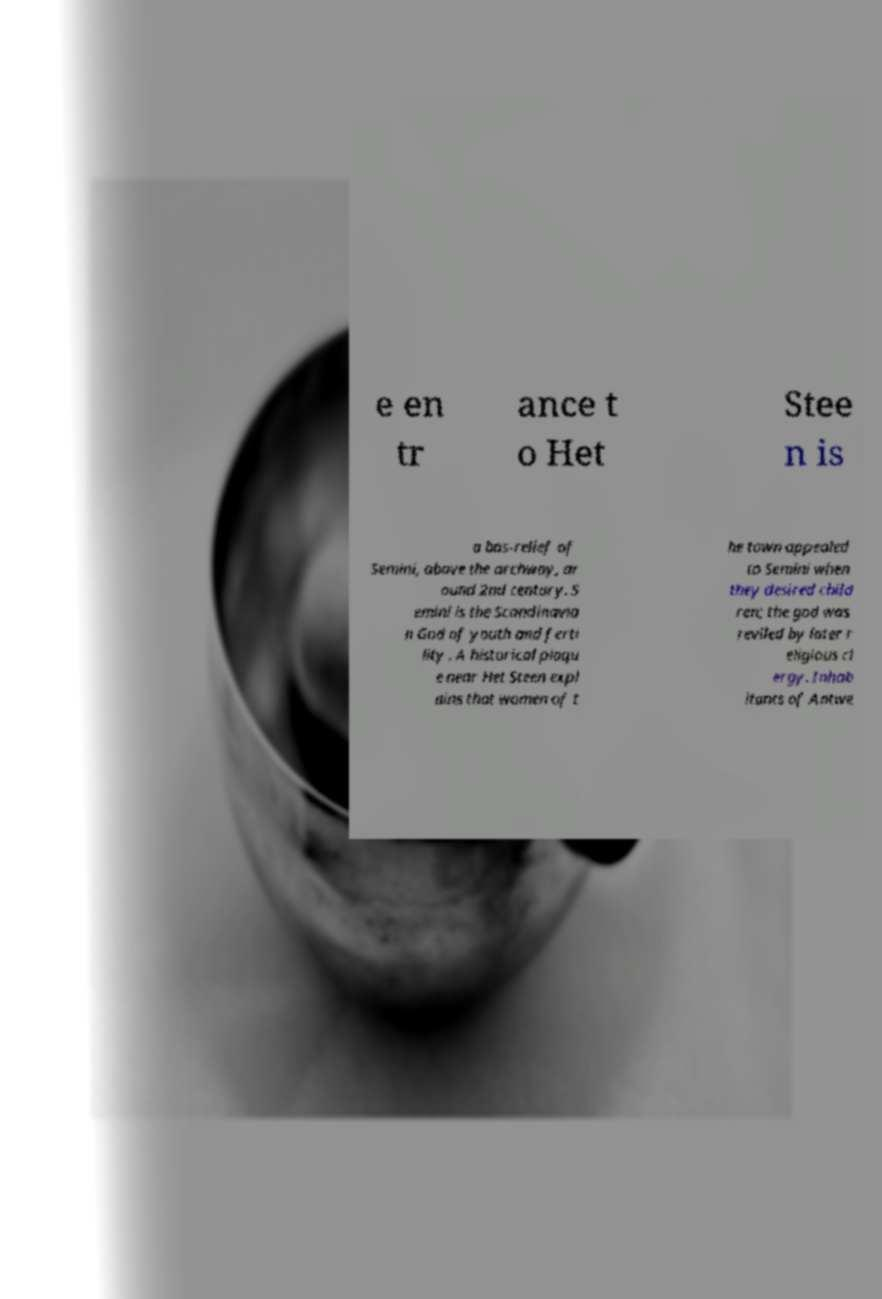Could you extract and type out the text from this image? e en tr ance t o Het Stee n is a bas-relief of Semini, above the archway, ar ound 2nd century. S emini is the Scandinavia n God of youth and ferti lity . A historical plaqu e near Het Steen expl ains that women of t he town appealed to Semini when they desired child ren; the god was reviled by later r eligious cl ergy. Inhab itants of Antwe 